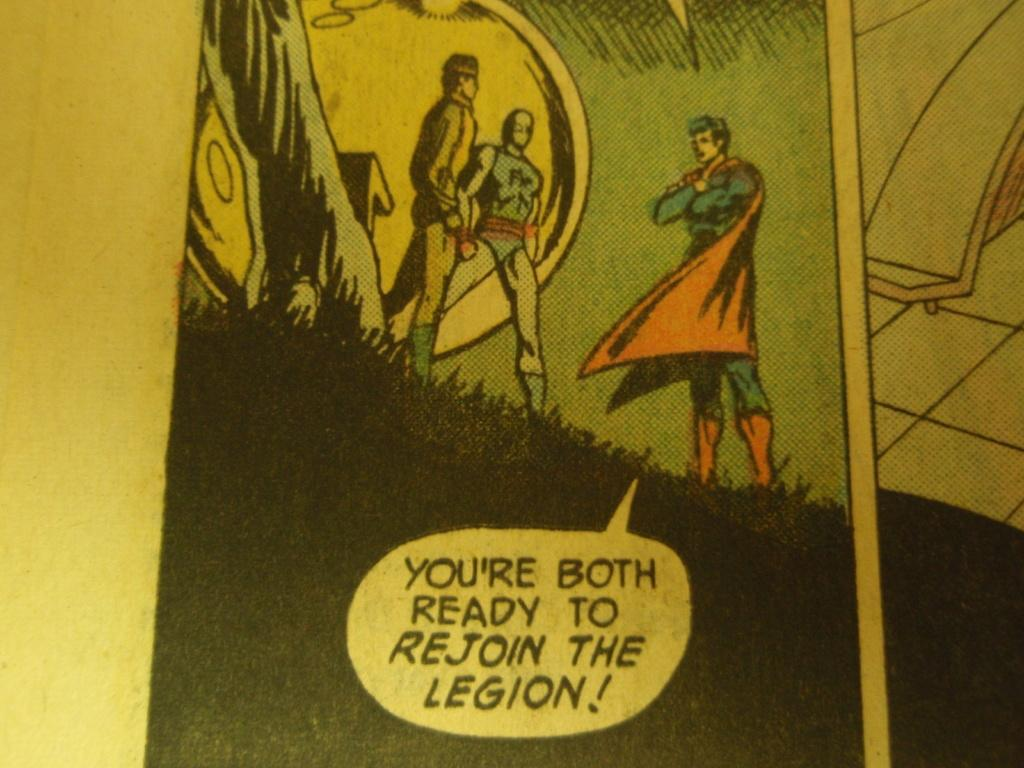<image>
Offer a succinct explanation of the picture presented. A page of a comic book with the words, You're both ready to rejoin the legion!, on the page. 